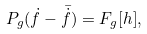Convert formula to latex. <formula><loc_0><loc_0><loc_500><loc_500>P _ { g } ( \dot { f } - \bar { \dot { f } } ) = F _ { g } [ h ] ,</formula> 